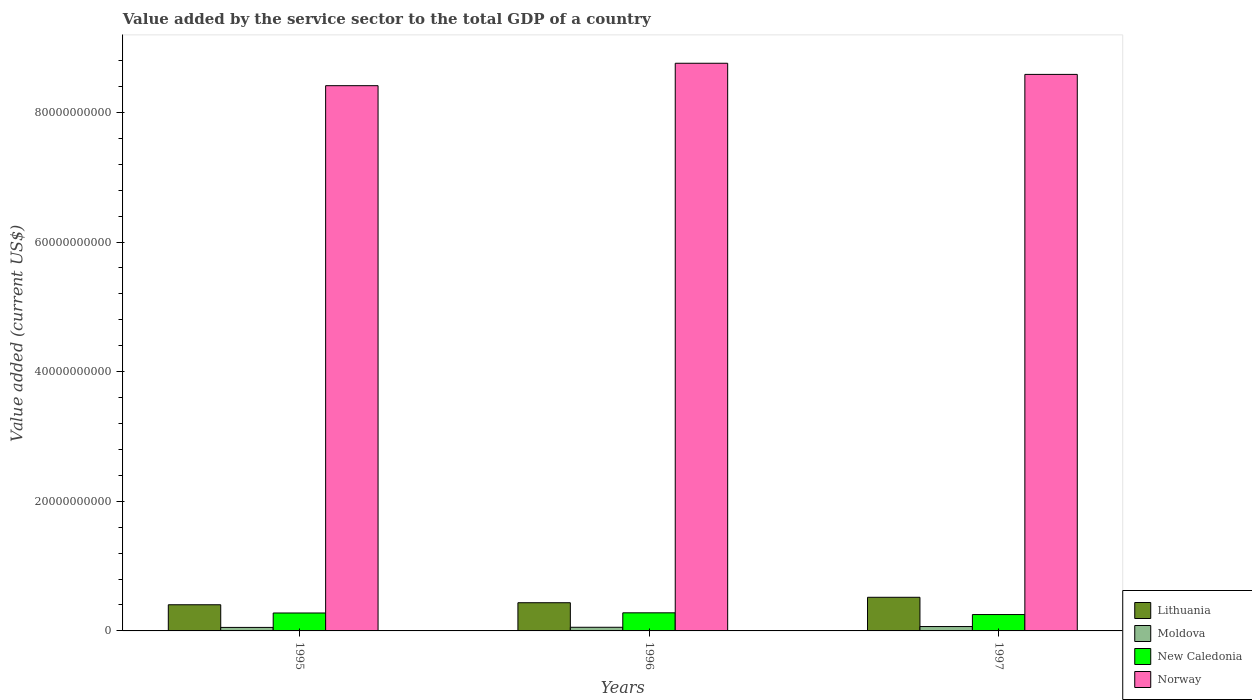How many different coloured bars are there?
Offer a terse response. 4. Are the number of bars per tick equal to the number of legend labels?
Offer a terse response. Yes. Are the number of bars on each tick of the X-axis equal?
Your answer should be very brief. Yes. How many bars are there on the 3rd tick from the right?
Your response must be concise. 4. What is the label of the 1st group of bars from the left?
Provide a succinct answer. 1995. What is the value added by the service sector to the total GDP in Lithuania in 1995?
Give a very brief answer. 4.04e+09. Across all years, what is the maximum value added by the service sector to the total GDP in New Caledonia?
Your answer should be very brief. 2.79e+09. Across all years, what is the minimum value added by the service sector to the total GDP in Lithuania?
Give a very brief answer. 4.04e+09. In which year was the value added by the service sector to the total GDP in New Caledonia maximum?
Make the answer very short. 1996. What is the total value added by the service sector to the total GDP in New Caledonia in the graph?
Your answer should be very brief. 8.08e+09. What is the difference between the value added by the service sector to the total GDP in New Caledonia in 1996 and that in 1997?
Keep it short and to the point. 2.67e+08. What is the difference between the value added by the service sector to the total GDP in New Caledonia in 1996 and the value added by the service sector to the total GDP in Lithuania in 1995?
Give a very brief answer. -1.25e+09. What is the average value added by the service sector to the total GDP in Moldova per year?
Offer a terse response. 5.93e+08. In the year 1997, what is the difference between the value added by the service sector to the total GDP in New Caledonia and value added by the service sector to the total GDP in Moldova?
Keep it short and to the point. 1.85e+09. What is the ratio of the value added by the service sector to the total GDP in Moldova in 1996 to that in 1997?
Your response must be concise. 0.83. Is the value added by the service sector to the total GDP in Lithuania in 1996 less than that in 1997?
Provide a succinct answer. Yes. What is the difference between the highest and the second highest value added by the service sector to the total GDP in New Caledonia?
Keep it short and to the point. 2.53e+07. What is the difference between the highest and the lowest value added by the service sector to the total GDP in Norway?
Provide a succinct answer. 3.46e+09. Is it the case that in every year, the sum of the value added by the service sector to the total GDP in Moldova and value added by the service sector to the total GDP in Lithuania is greater than the sum of value added by the service sector to the total GDP in Norway and value added by the service sector to the total GDP in New Caledonia?
Your answer should be compact. Yes. What does the 3rd bar from the left in 1995 represents?
Make the answer very short. New Caledonia. What does the 1st bar from the right in 1996 represents?
Give a very brief answer. Norway. How many bars are there?
Make the answer very short. 12. How many years are there in the graph?
Your answer should be very brief. 3. What is the difference between two consecutive major ticks on the Y-axis?
Make the answer very short. 2.00e+1. Are the values on the major ticks of Y-axis written in scientific E-notation?
Make the answer very short. No. Does the graph contain any zero values?
Ensure brevity in your answer.  No. Does the graph contain grids?
Your answer should be compact. No. Where does the legend appear in the graph?
Ensure brevity in your answer.  Bottom right. What is the title of the graph?
Offer a very short reply. Value added by the service sector to the total GDP of a country. What is the label or title of the X-axis?
Make the answer very short. Years. What is the label or title of the Y-axis?
Your answer should be compact. Value added (current US$). What is the Value added (current US$) in Lithuania in 1995?
Offer a very short reply. 4.04e+09. What is the Value added (current US$) of Moldova in 1995?
Make the answer very short. 5.41e+08. What is the Value added (current US$) in New Caledonia in 1995?
Provide a short and direct response. 2.77e+09. What is the Value added (current US$) of Norway in 1995?
Your answer should be very brief. 8.41e+1. What is the Value added (current US$) in Lithuania in 1996?
Keep it short and to the point. 4.35e+09. What is the Value added (current US$) of Moldova in 1996?
Keep it short and to the point. 5.62e+08. What is the Value added (current US$) in New Caledonia in 1996?
Ensure brevity in your answer.  2.79e+09. What is the Value added (current US$) of Norway in 1996?
Offer a terse response. 8.76e+1. What is the Value added (current US$) in Lithuania in 1997?
Ensure brevity in your answer.  5.19e+09. What is the Value added (current US$) in Moldova in 1997?
Provide a short and direct response. 6.76e+08. What is the Value added (current US$) in New Caledonia in 1997?
Provide a short and direct response. 2.53e+09. What is the Value added (current US$) of Norway in 1997?
Keep it short and to the point. 8.59e+1. Across all years, what is the maximum Value added (current US$) in Lithuania?
Provide a succinct answer. 5.19e+09. Across all years, what is the maximum Value added (current US$) in Moldova?
Ensure brevity in your answer.  6.76e+08. Across all years, what is the maximum Value added (current US$) in New Caledonia?
Give a very brief answer. 2.79e+09. Across all years, what is the maximum Value added (current US$) of Norway?
Make the answer very short. 8.76e+1. Across all years, what is the minimum Value added (current US$) of Lithuania?
Your answer should be very brief. 4.04e+09. Across all years, what is the minimum Value added (current US$) of Moldova?
Your response must be concise. 5.41e+08. Across all years, what is the minimum Value added (current US$) of New Caledonia?
Your answer should be very brief. 2.53e+09. Across all years, what is the minimum Value added (current US$) in Norway?
Your answer should be very brief. 8.41e+1. What is the total Value added (current US$) in Lithuania in the graph?
Give a very brief answer. 1.36e+1. What is the total Value added (current US$) in Moldova in the graph?
Your response must be concise. 1.78e+09. What is the total Value added (current US$) in New Caledonia in the graph?
Your answer should be very brief. 8.08e+09. What is the total Value added (current US$) in Norway in the graph?
Ensure brevity in your answer.  2.58e+11. What is the difference between the Value added (current US$) of Lithuania in 1995 and that in 1996?
Make the answer very short. -3.12e+08. What is the difference between the Value added (current US$) of Moldova in 1995 and that in 1996?
Your answer should be very brief. -2.10e+07. What is the difference between the Value added (current US$) of New Caledonia in 1995 and that in 1996?
Give a very brief answer. -2.53e+07. What is the difference between the Value added (current US$) of Norway in 1995 and that in 1996?
Provide a succinct answer. -3.46e+09. What is the difference between the Value added (current US$) of Lithuania in 1995 and that in 1997?
Provide a short and direct response. -1.15e+09. What is the difference between the Value added (current US$) of Moldova in 1995 and that in 1997?
Your answer should be compact. -1.35e+08. What is the difference between the Value added (current US$) in New Caledonia in 1995 and that in 1997?
Provide a succinct answer. 2.41e+08. What is the difference between the Value added (current US$) in Norway in 1995 and that in 1997?
Offer a terse response. -1.74e+09. What is the difference between the Value added (current US$) in Lithuania in 1996 and that in 1997?
Your answer should be compact. -8.39e+08. What is the difference between the Value added (current US$) in Moldova in 1996 and that in 1997?
Offer a very short reply. -1.14e+08. What is the difference between the Value added (current US$) in New Caledonia in 1996 and that in 1997?
Your answer should be compact. 2.67e+08. What is the difference between the Value added (current US$) of Norway in 1996 and that in 1997?
Offer a very short reply. 1.72e+09. What is the difference between the Value added (current US$) of Lithuania in 1995 and the Value added (current US$) of Moldova in 1996?
Keep it short and to the point. 3.48e+09. What is the difference between the Value added (current US$) of Lithuania in 1995 and the Value added (current US$) of New Caledonia in 1996?
Keep it short and to the point. 1.25e+09. What is the difference between the Value added (current US$) in Lithuania in 1995 and the Value added (current US$) in Norway in 1996?
Your answer should be very brief. -8.35e+1. What is the difference between the Value added (current US$) in Moldova in 1995 and the Value added (current US$) in New Caledonia in 1996?
Provide a succinct answer. -2.25e+09. What is the difference between the Value added (current US$) in Moldova in 1995 and the Value added (current US$) in Norway in 1996?
Offer a very short reply. -8.70e+1. What is the difference between the Value added (current US$) of New Caledonia in 1995 and the Value added (current US$) of Norway in 1996?
Your response must be concise. -8.48e+1. What is the difference between the Value added (current US$) of Lithuania in 1995 and the Value added (current US$) of Moldova in 1997?
Your answer should be very brief. 3.36e+09. What is the difference between the Value added (current US$) in Lithuania in 1995 and the Value added (current US$) in New Caledonia in 1997?
Your response must be concise. 1.51e+09. What is the difference between the Value added (current US$) in Lithuania in 1995 and the Value added (current US$) in Norway in 1997?
Give a very brief answer. -8.18e+1. What is the difference between the Value added (current US$) in Moldova in 1995 and the Value added (current US$) in New Caledonia in 1997?
Offer a terse response. -1.98e+09. What is the difference between the Value added (current US$) of Moldova in 1995 and the Value added (current US$) of Norway in 1997?
Make the answer very short. -8.53e+1. What is the difference between the Value added (current US$) of New Caledonia in 1995 and the Value added (current US$) of Norway in 1997?
Keep it short and to the point. -8.31e+1. What is the difference between the Value added (current US$) of Lithuania in 1996 and the Value added (current US$) of Moldova in 1997?
Keep it short and to the point. 3.67e+09. What is the difference between the Value added (current US$) of Lithuania in 1996 and the Value added (current US$) of New Caledonia in 1997?
Provide a short and direct response. 1.82e+09. What is the difference between the Value added (current US$) in Lithuania in 1996 and the Value added (current US$) in Norway in 1997?
Provide a succinct answer. -8.15e+1. What is the difference between the Value added (current US$) in Moldova in 1996 and the Value added (current US$) in New Caledonia in 1997?
Ensure brevity in your answer.  -1.96e+09. What is the difference between the Value added (current US$) in Moldova in 1996 and the Value added (current US$) in Norway in 1997?
Your answer should be very brief. -8.53e+1. What is the difference between the Value added (current US$) of New Caledonia in 1996 and the Value added (current US$) of Norway in 1997?
Keep it short and to the point. -8.31e+1. What is the average Value added (current US$) in Lithuania per year?
Make the answer very short. 4.53e+09. What is the average Value added (current US$) in Moldova per year?
Offer a terse response. 5.93e+08. What is the average Value added (current US$) in New Caledonia per year?
Your response must be concise. 2.69e+09. What is the average Value added (current US$) in Norway per year?
Give a very brief answer. 8.59e+1. In the year 1995, what is the difference between the Value added (current US$) in Lithuania and Value added (current US$) in Moldova?
Your response must be concise. 3.50e+09. In the year 1995, what is the difference between the Value added (current US$) of Lithuania and Value added (current US$) of New Caledonia?
Give a very brief answer. 1.27e+09. In the year 1995, what is the difference between the Value added (current US$) in Lithuania and Value added (current US$) in Norway?
Your response must be concise. -8.01e+1. In the year 1995, what is the difference between the Value added (current US$) in Moldova and Value added (current US$) in New Caledonia?
Your response must be concise. -2.23e+09. In the year 1995, what is the difference between the Value added (current US$) of Moldova and Value added (current US$) of Norway?
Ensure brevity in your answer.  -8.36e+1. In the year 1995, what is the difference between the Value added (current US$) of New Caledonia and Value added (current US$) of Norway?
Keep it short and to the point. -8.14e+1. In the year 1996, what is the difference between the Value added (current US$) of Lithuania and Value added (current US$) of Moldova?
Provide a succinct answer. 3.79e+09. In the year 1996, what is the difference between the Value added (current US$) in Lithuania and Value added (current US$) in New Caledonia?
Provide a short and direct response. 1.56e+09. In the year 1996, what is the difference between the Value added (current US$) of Lithuania and Value added (current US$) of Norway?
Your answer should be compact. -8.32e+1. In the year 1996, what is the difference between the Value added (current US$) of Moldova and Value added (current US$) of New Caledonia?
Your answer should be very brief. -2.23e+09. In the year 1996, what is the difference between the Value added (current US$) in Moldova and Value added (current US$) in Norway?
Provide a short and direct response. -8.70e+1. In the year 1996, what is the difference between the Value added (current US$) of New Caledonia and Value added (current US$) of Norway?
Keep it short and to the point. -8.48e+1. In the year 1997, what is the difference between the Value added (current US$) of Lithuania and Value added (current US$) of Moldova?
Your response must be concise. 4.51e+09. In the year 1997, what is the difference between the Value added (current US$) of Lithuania and Value added (current US$) of New Caledonia?
Provide a succinct answer. 2.66e+09. In the year 1997, what is the difference between the Value added (current US$) of Lithuania and Value added (current US$) of Norway?
Make the answer very short. -8.07e+1. In the year 1997, what is the difference between the Value added (current US$) of Moldova and Value added (current US$) of New Caledonia?
Your answer should be compact. -1.85e+09. In the year 1997, what is the difference between the Value added (current US$) in Moldova and Value added (current US$) in Norway?
Your answer should be very brief. -8.52e+1. In the year 1997, what is the difference between the Value added (current US$) in New Caledonia and Value added (current US$) in Norway?
Offer a terse response. -8.33e+1. What is the ratio of the Value added (current US$) of Lithuania in 1995 to that in 1996?
Offer a terse response. 0.93. What is the ratio of the Value added (current US$) of Moldova in 1995 to that in 1996?
Provide a succinct answer. 0.96. What is the ratio of the Value added (current US$) in New Caledonia in 1995 to that in 1996?
Make the answer very short. 0.99. What is the ratio of the Value added (current US$) in Norway in 1995 to that in 1996?
Offer a terse response. 0.96. What is the ratio of the Value added (current US$) of Lithuania in 1995 to that in 1997?
Make the answer very short. 0.78. What is the ratio of the Value added (current US$) in Moldova in 1995 to that in 1997?
Provide a succinct answer. 0.8. What is the ratio of the Value added (current US$) in New Caledonia in 1995 to that in 1997?
Keep it short and to the point. 1.1. What is the ratio of the Value added (current US$) of Norway in 1995 to that in 1997?
Give a very brief answer. 0.98. What is the ratio of the Value added (current US$) of Lithuania in 1996 to that in 1997?
Offer a very short reply. 0.84. What is the ratio of the Value added (current US$) in Moldova in 1996 to that in 1997?
Your answer should be very brief. 0.83. What is the ratio of the Value added (current US$) of New Caledonia in 1996 to that in 1997?
Offer a terse response. 1.11. What is the difference between the highest and the second highest Value added (current US$) in Lithuania?
Make the answer very short. 8.39e+08. What is the difference between the highest and the second highest Value added (current US$) in Moldova?
Offer a very short reply. 1.14e+08. What is the difference between the highest and the second highest Value added (current US$) of New Caledonia?
Your answer should be compact. 2.53e+07. What is the difference between the highest and the second highest Value added (current US$) in Norway?
Keep it short and to the point. 1.72e+09. What is the difference between the highest and the lowest Value added (current US$) in Lithuania?
Ensure brevity in your answer.  1.15e+09. What is the difference between the highest and the lowest Value added (current US$) in Moldova?
Offer a terse response. 1.35e+08. What is the difference between the highest and the lowest Value added (current US$) of New Caledonia?
Offer a terse response. 2.67e+08. What is the difference between the highest and the lowest Value added (current US$) in Norway?
Your answer should be compact. 3.46e+09. 